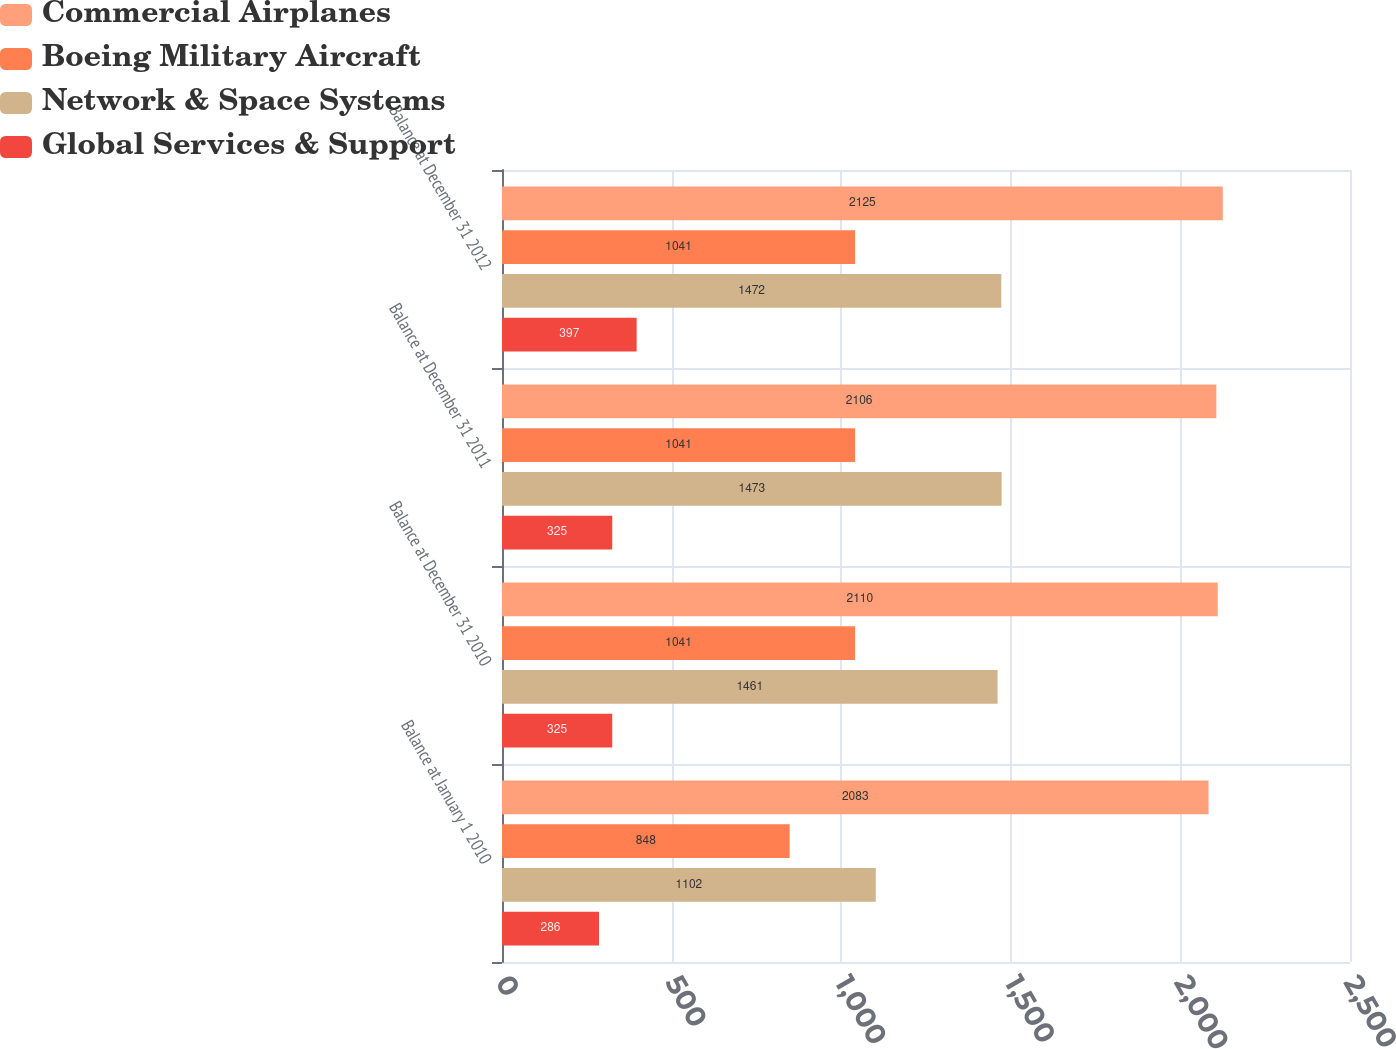<chart> <loc_0><loc_0><loc_500><loc_500><stacked_bar_chart><ecel><fcel>Balance at January 1 2010<fcel>Balance at December 31 2010<fcel>Balance at December 31 2011<fcel>Balance at December 31 2012<nl><fcel>Commercial Airplanes<fcel>2083<fcel>2110<fcel>2106<fcel>2125<nl><fcel>Boeing Military Aircraft<fcel>848<fcel>1041<fcel>1041<fcel>1041<nl><fcel>Network & Space Systems<fcel>1102<fcel>1461<fcel>1473<fcel>1472<nl><fcel>Global Services & Support<fcel>286<fcel>325<fcel>325<fcel>397<nl></chart> 